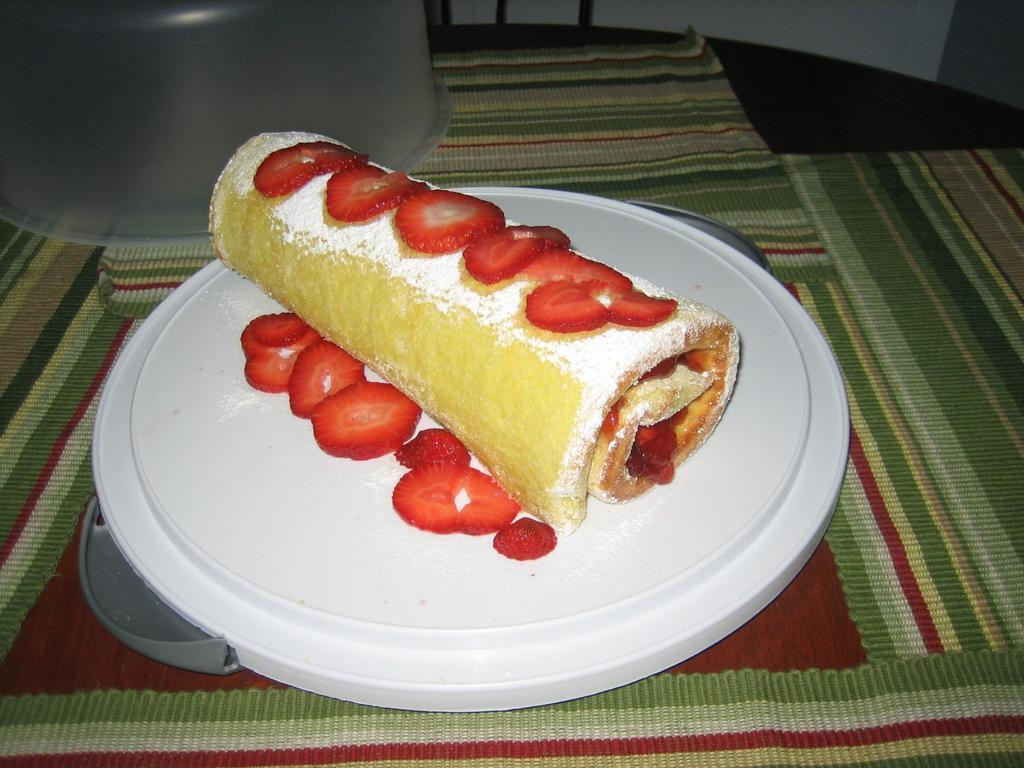What is the main subject of the image? The main subject of the image is food. Where is the food located in the image? The food is in the center of the image. What else can be seen in the image besides the food? There is a vessel in the image. Where is the vessel located in the image? The vessel is on the table. What is the vessel resting on in the image? The vessel is on top of something in the image. What type of office furniture is visible in the image? There is no office furniture present in the image; it features food, a vessel, and a table. 